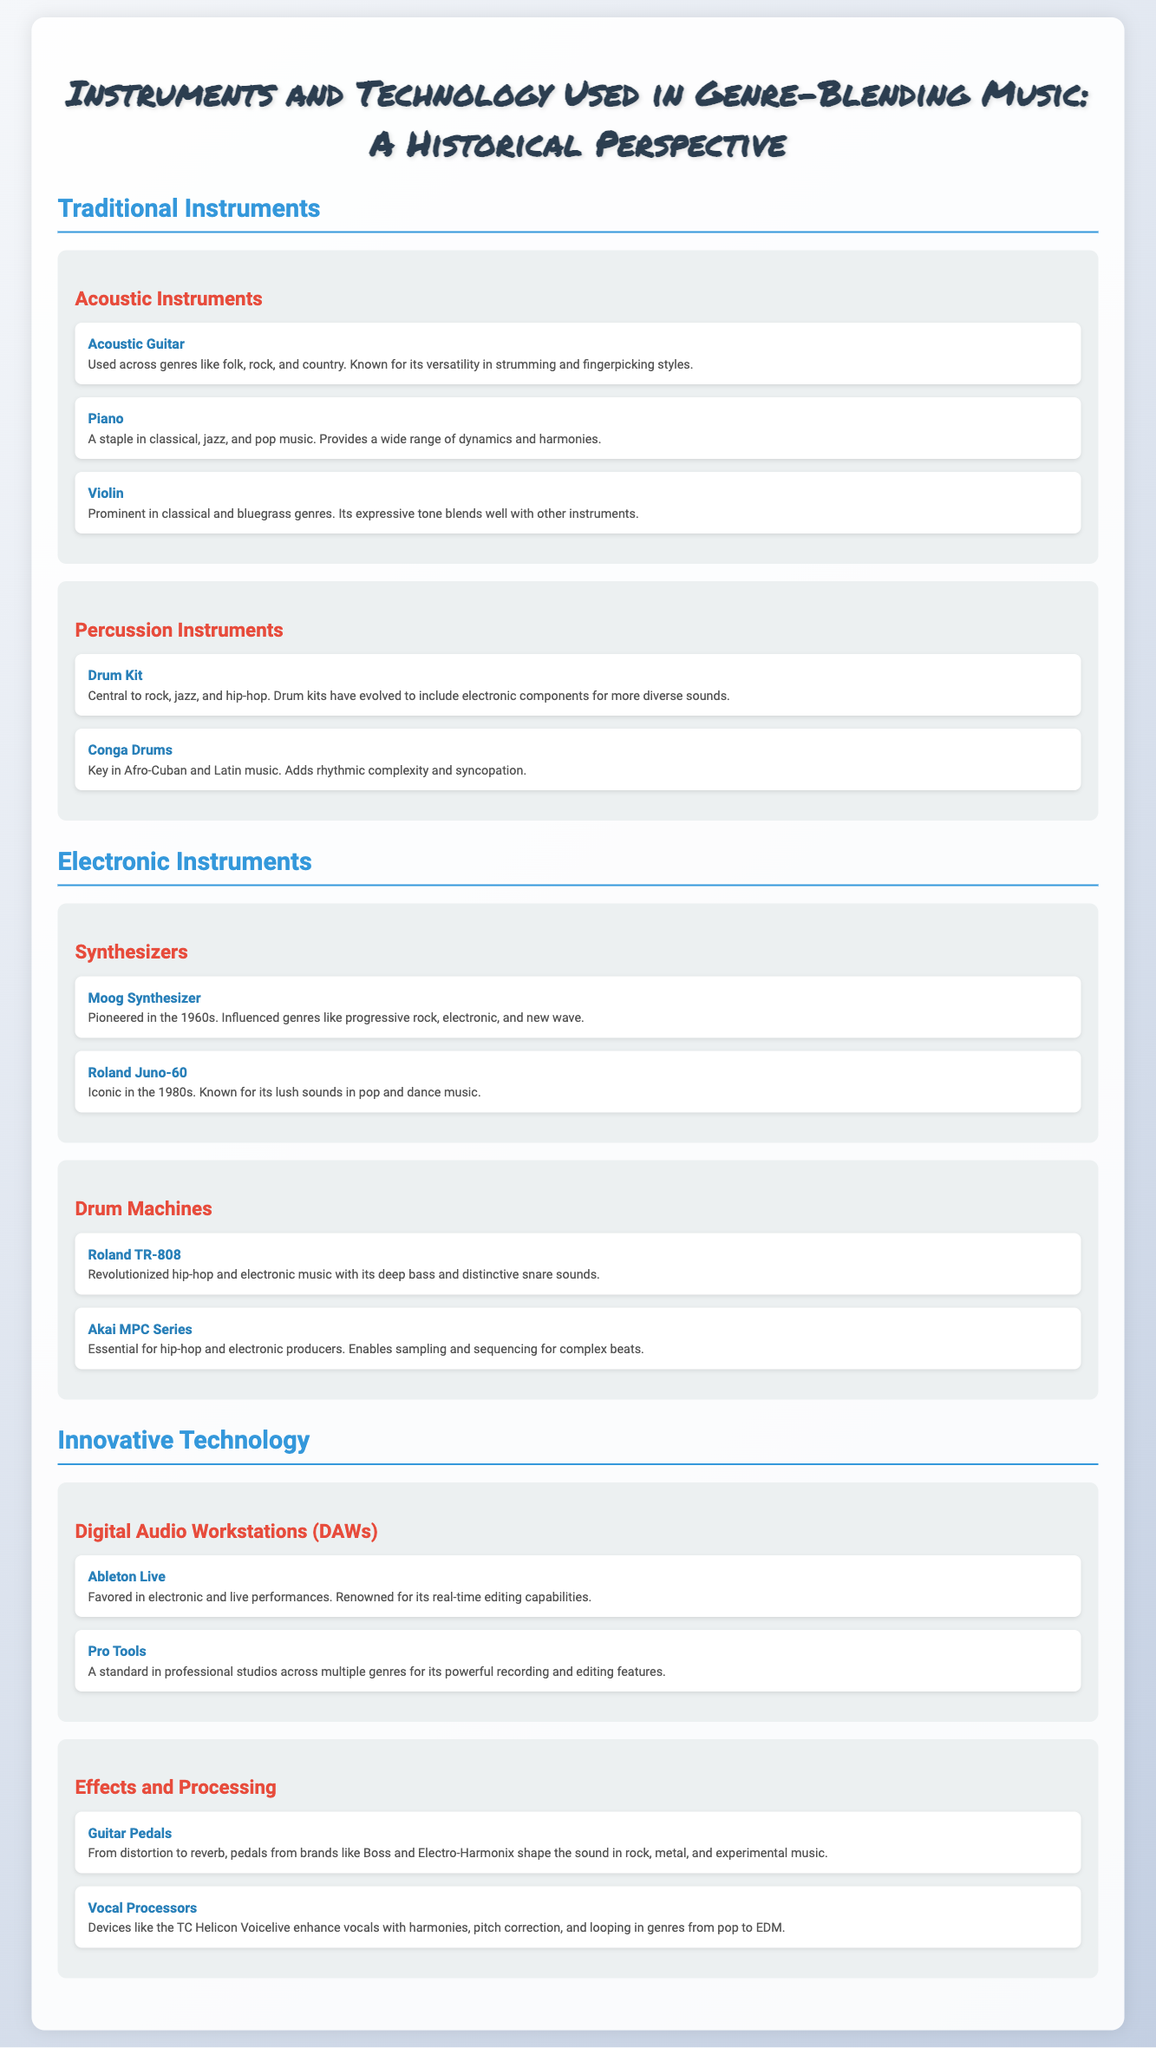What are the examples of acoustic instruments listed? The document lists three acoustic instruments under "Traditional Instruments": Acoustic Guitar, Piano, and Violin.
Answer: Acoustic Guitar, Piano, Violin Which electronic instrument is known for its influence on progressive rock? The Moog Synthesizer is mentioned as having pioneered in the 1960s and influenced genres like progressive rock.
Answer: Moog Synthesizer How many types of percussion instruments are mentioned? The section on percussion instruments includes two types: Drum Kit and Conga Drums.
Answer: 2 What is the standard digital audio workstation mentioned for professional studios? Pro Tools is identified as a standard in professional studios across multiple genres.
Answer: Pro Tools Which vocal processor is listed in the document? The TC Helicon Voicelive is mentioned as enhancing vocals with various features in different genres.
Answer: TC Helicon Voicelive What technology does Ableton Live relate to? Ableton Live is favored in electronic and live performances, which indicates it relates to Digital Audio Workstations.
Answer: Digital Audio Workstations Which acoustic instrument is described as expressive and prominent in bluegrass? The document describes the Violin as expressive and prominent in bluegrass genres.
Answer: Violin What instrument is essential for hip-hop producers according to the infographic? The Akai MPC Series is stated to be essential for hip-hop and electronic producers.
Answer: Akai MPC Series Which synthesizer is iconic in the 1980s known for lush sounds? The Roland Juno-60 is noted for its iconic status in the 1980s and its lush sounds.
Answer: Roland Juno-60 